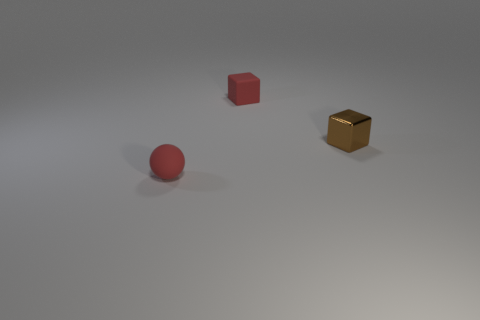How does the lighting in this scene affect the mood conveyed by the image? The lighting is soft and diffused, casting gentle shadows and creating a serene, slightly contemplative atmosphere. It accentuates the simplicity and clean lines of the shapes. 